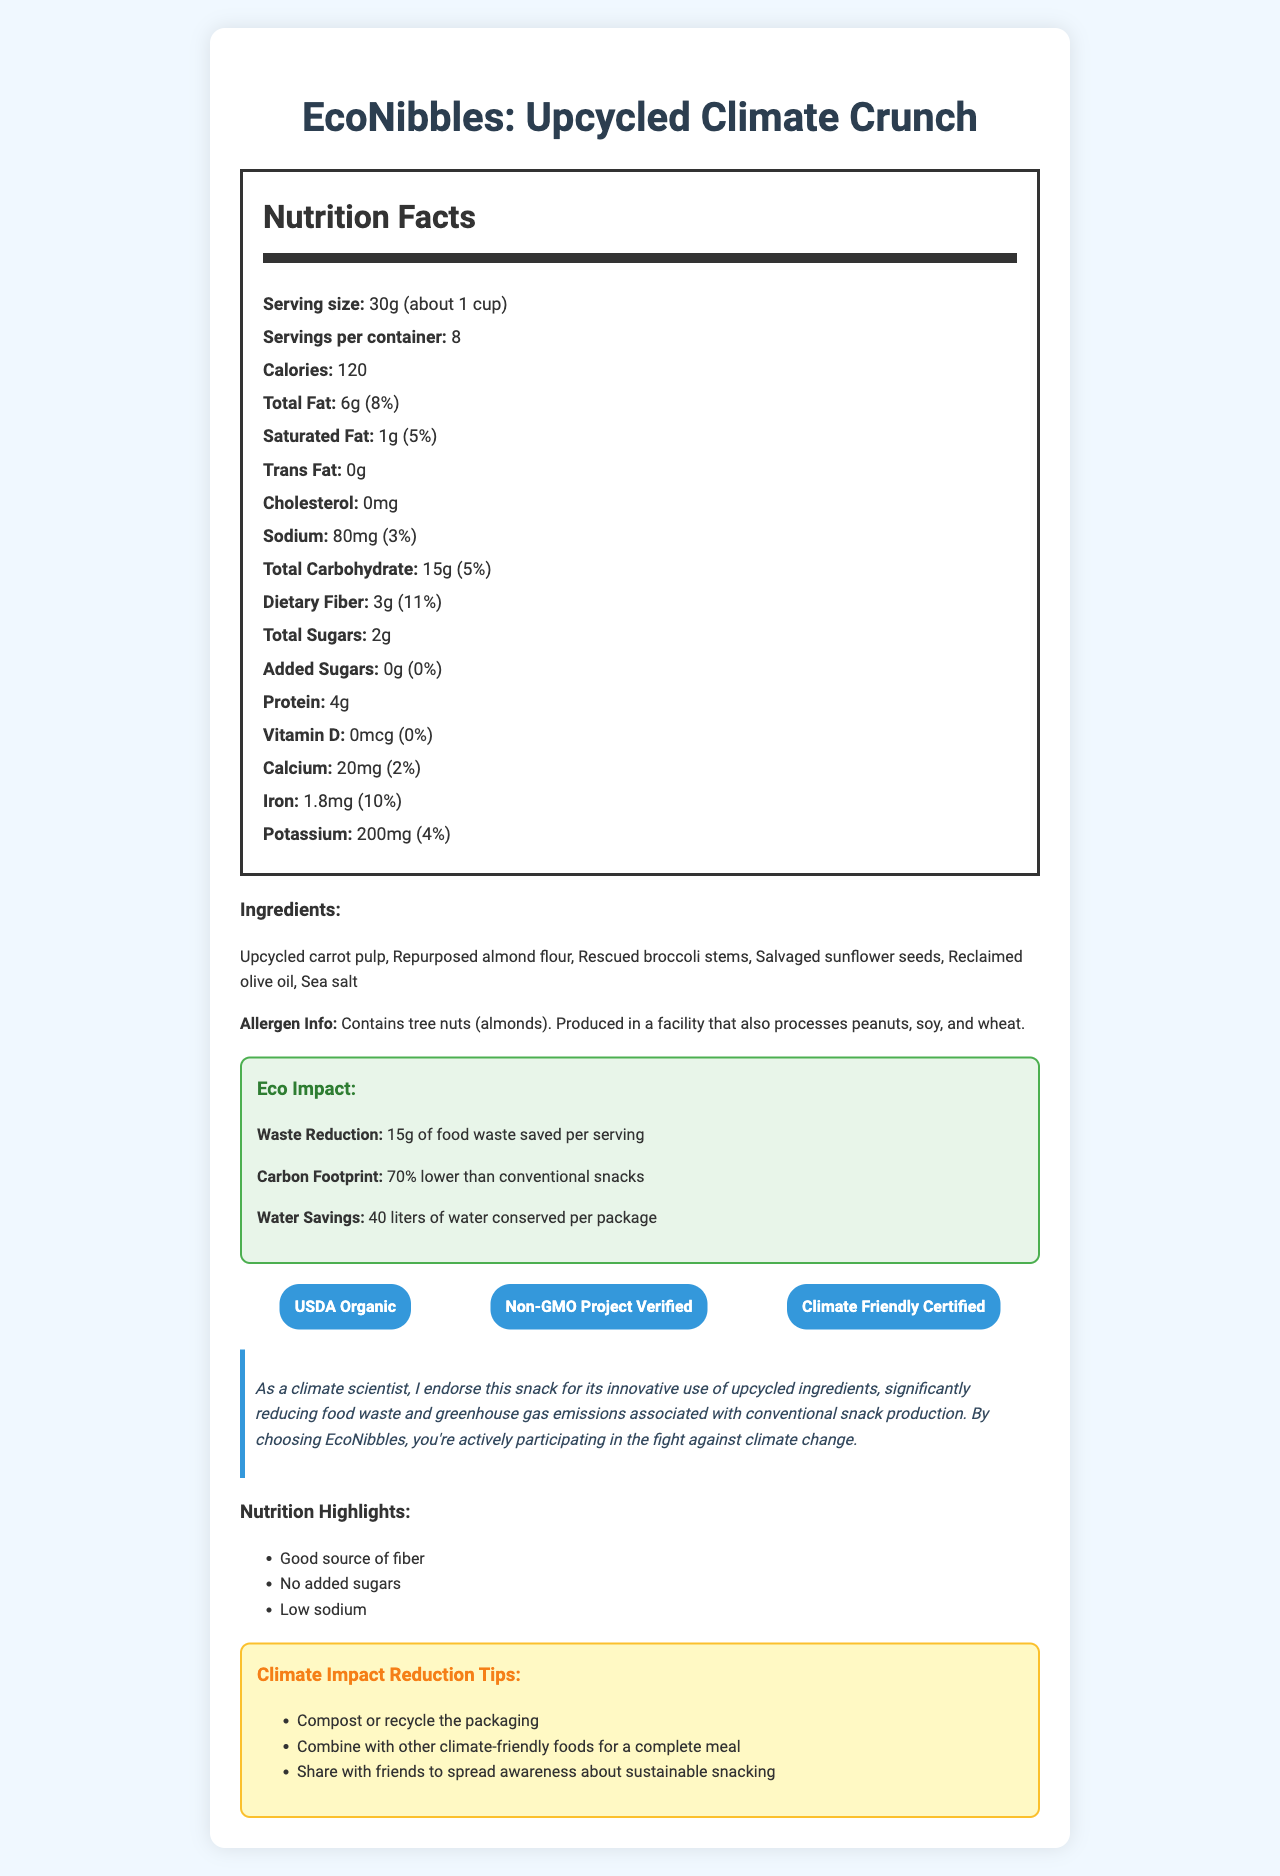What is the serving size for EcoNibbles? According to the document, the serving size is specifically listed as 30g (about 1 cup).
Answer: 30g (about 1 cup) How many servings are there per container? The document indicates that there are 8 servings per container.
Answer: 8 How much fiber does one serving provide? The nutrient breakdown in the document shows that one serving contains 3g of dietary fiber.
Answer: 3g What percentage of the daily value for iron does one serving of EcoNibbles provide? The nutrition information states that one serving provides 10% of the daily value for iron.
Answer: 10% What are the two main benefits listed under the nutrition highlights? In the nutrition highlights section, the document lists "Good source of fiber" and "No added sugars" as two of the main benefits.
Answer: Good source of fiber, No added sugars Which of the following ingredients is not included in EcoNibbles: 1. Upcycled carrot pulp, 2. Repurposed almond flour, 3. Fried potato chips, 4. Rescued broccoli stems The ingredient list includes upcycled carrot pulp, repurposed almond flour, and rescued broccoli stems, but not fried potato chips.
Answer: 3 What is the total fat content per serving? A. 3g B. 6g C. 9g The document states that the total fat content per serving is 6g.
Answer: B What certifications does EcoNibbles hold? 1. USDA Organic 2. Non-GMO Project Verified 3. Fair Trade Certified 4. Climate Friendly Certified The certifications listed in the document are USDA Organic, Non-GMO Project Verified, and Climate Friendly Certified, but not Fair Trade Certified.
Answer: 1, 2, 4 Does EcoNibbles have any added sugars? The nutrition facts indicate that added sugars are 0g, implying that there are no added sugars in the product.
Answer: No Can EcoNibbles help reduce food waste? According to the eco impact section, EcoNibbles saves 15g of food waste per serving.
Answer: Yes Summarize the main focus of the document. The document focuses on EcoNibbles, emphasizing its use of upcycled ingredients, its various nutritional benefits, significant environmental impact, and its certifications, showing how it contributes to both personal health and environmental sustainability.
Answer: EcoNibbles: Upcycled Climate Crunch is a climate-friendly snack made from upcycled ingredients, which highlights its nutritional benefits, waste reduction, lower carbon footprint, and water savings. It is certified USDA Organic, Non-GMO Project Verified, and Climate Friendly Certified. What is the process of upcycling, as mentioned in the document? The document mentions the use of upcycled ingredients but does not provide a definition or process description for upcycling.
Answer: Not enough information 